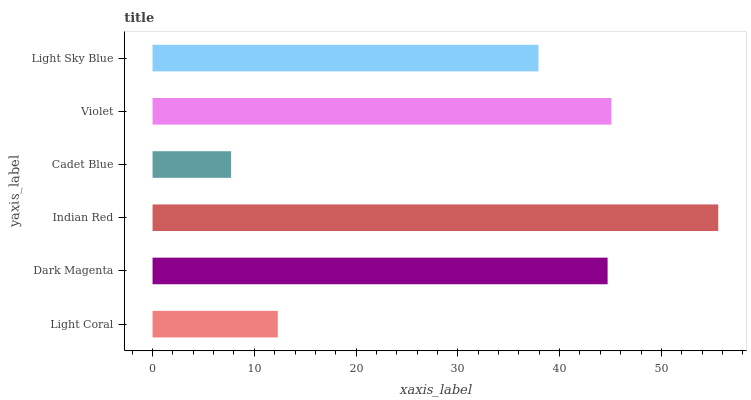Is Cadet Blue the minimum?
Answer yes or no. Yes. Is Indian Red the maximum?
Answer yes or no. Yes. Is Dark Magenta the minimum?
Answer yes or no. No. Is Dark Magenta the maximum?
Answer yes or no. No. Is Dark Magenta greater than Light Coral?
Answer yes or no. Yes. Is Light Coral less than Dark Magenta?
Answer yes or no. Yes. Is Light Coral greater than Dark Magenta?
Answer yes or no. No. Is Dark Magenta less than Light Coral?
Answer yes or no. No. Is Dark Magenta the high median?
Answer yes or no. Yes. Is Light Sky Blue the low median?
Answer yes or no. Yes. Is Light Sky Blue the high median?
Answer yes or no. No. Is Dark Magenta the low median?
Answer yes or no. No. 